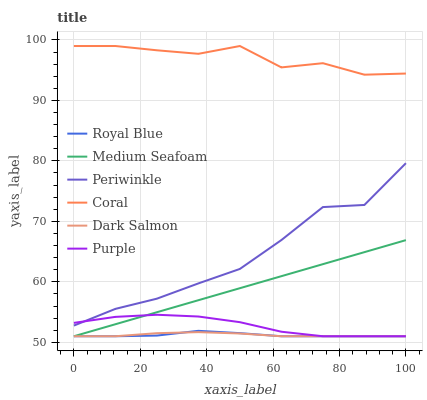Does Royal Blue have the minimum area under the curve?
Answer yes or no. Yes. Does Coral have the maximum area under the curve?
Answer yes or no. Yes. Does Dark Salmon have the minimum area under the curve?
Answer yes or no. No. Does Dark Salmon have the maximum area under the curve?
Answer yes or no. No. Is Medium Seafoam the smoothest?
Answer yes or no. Yes. Is Periwinkle the roughest?
Answer yes or no. Yes. Is Coral the smoothest?
Answer yes or no. No. Is Coral the roughest?
Answer yes or no. No. Does Purple have the lowest value?
Answer yes or no. Yes. Does Coral have the lowest value?
Answer yes or no. No. Does Coral have the highest value?
Answer yes or no. Yes. Does Dark Salmon have the highest value?
Answer yes or no. No. Is Royal Blue less than Coral?
Answer yes or no. Yes. Is Coral greater than Royal Blue?
Answer yes or no. Yes. Does Dark Salmon intersect Purple?
Answer yes or no. Yes. Is Dark Salmon less than Purple?
Answer yes or no. No. Is Dark Salmon greater than Purple?
Answer yes or no. No. Does Royal Blue intersect Coral?
Answer yes or no. No. 